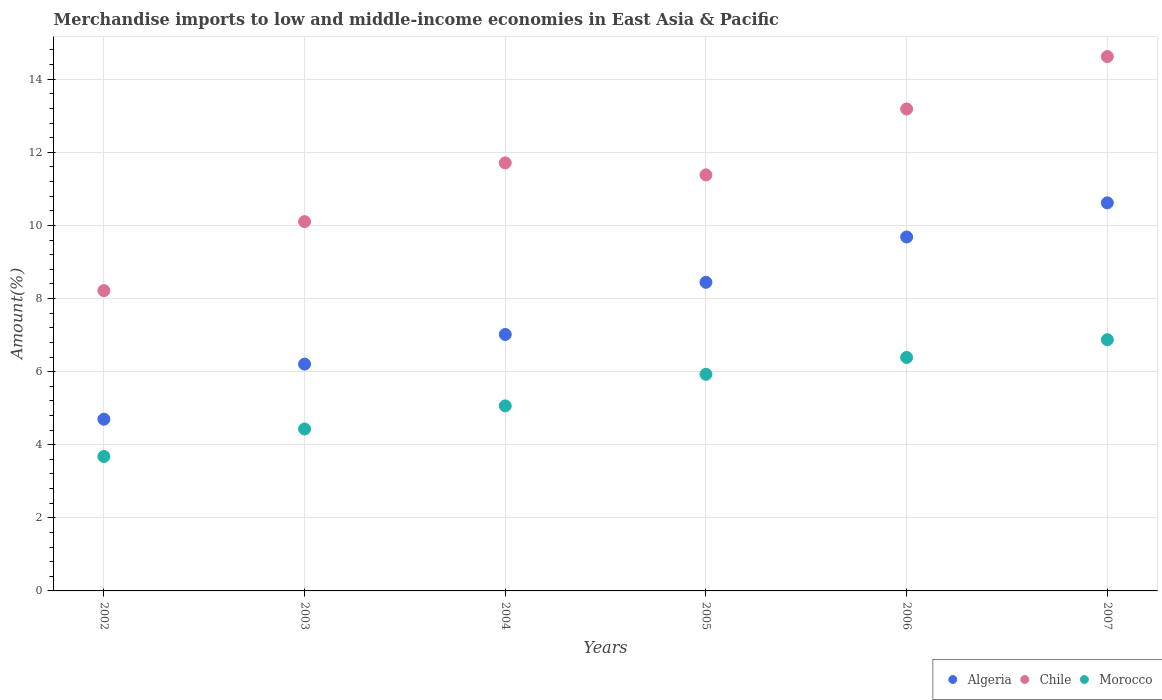How many different coloured dotlines are there?
Give a very brief answer. 3. Is the number of dotlines equal to the number of legend labels?
Offer a terse response. Yes. What is the percentage of amount earned from merchandise imports in Morocco in 2003?
Ensure brevity in your answer.  4.43. Across all years, what is the maximum percentage of amount earned from merchandise imports in Morocco?
Ensure brevity in your answer.  6.87. Across all years, what is the minimum percentage of amount earned from merchandise imports in Morocco?
Provide a succinct answer. 3.68. In which year was the percentage of amount earned from merchandise imports in Chile maximum?
Keep it short and to the point. 2007. What is the total percentage of amount earned from merchandise imports in Algeria in the graph?
Offer a terse response. 46.67. What is the difference between the percentage of amount earned from merchandise imports in Chile in 2003 and that in 2005?
Provide a short and direct response. -1.28. What is the difference between the percentage of amount earned from merchandise imports in Algeria in 2004 and the percentage of amount earned from merchandise imports in Morocco in 2007?
Offer a very short reply. 0.14. What is the average percentage of amount earned from merchandise imports in Chile per year?
Your answer should be compact. 11.54. In the year 2006, what is the difference between the percentage of amount earned from merchandise imports in Morocco and percentage of amount earned from merchandise imports in Algeria?
Keep it short and to the point. -3.3. In how many years, is the percentage of amount earned from merchandise imports in Morocco greater than 4.8 %?
Ensure brevity in your answer.  4. What is the ratio of the percentage of amount earned from merchandise imports in Morocco in 2004 to that in 2005?
Your answer should be compact. 0.85. Is the percentage of amount earned from merchandise imports in Morocco in 2002 less than that in 2004?
Keep it short and to the point. Yes. Is the difference between the percentage of amount earned from merchandise imports in Morocco in 2005 and 2007 greater than the difference between the percentage of amount earned from merchandise imports in Algeria in 2005 and 2007?
Give a very brief answer. Yes. What is the difference between the highest and the second highest percentage of amount earned from merchandise imports in Morocco?
Ensure brevity in your answer.  0.49. What is the difference between the highest and the lowest percentage of amount earned from merchandise imports in Chile?
Your answer should be compact. 6.4. Is the percentage of amount earned from merchandise imports in Morocco strictly greater than the percentage of amount earned from merchandise imports in Chile over the years?
Provide a succinct answer. No. How many dotlines are there?
Ensure brevity in your answer.  3. What is the difference between two consecutive major ticks on the Y-axis?
Provide a succinct answer. 2. Are the values on the major ticks of Y-axis written in scientific E-notation?
Keep it short and to the point. No. Does the graph contain any zero values?
Ensure brevity in your answer.  No. Does the graph contain grids?
Provide a short and direct response. Yes. How many legend labels are there?
Keep it short and to the point. 3. How are the legend labels stacked?
Offer a terse response. Horizontal. What is the title of the graph?
Offer a very short reply. Merchandise imports to low and middle-income economies in East Asia & Pacific. What is the label or title of the Y-axis?
Make the answer very short. Amount(%). What is the Amount(%) in Algeria in 2002?
Your response must be concise. 4.7. What is the Amount(%) of Chile in 2002?
Provide a succinct answer. 8.22. What is the Amount(%) in Morocco in 2002?
Your response must be concise. 3.68. What is the Amount(%) of Algeria in 2003?
Ensure brevity in your answer.  6.21. What is the Amount(%) in Chile in 2003?
Provide a short and direct response. 10.1. What is the Amount(%) in Morocco in 2003?
Your answer should be compact. 4.43. What is the Amount(%) of Algeria in 2004?
Offer a very short reply. 7.02. What is the Amount(%) of Chile in 2004?
Give a very brief answer. 11.71. What is the Amount(%) of Morocco in 2004?
Your response must be concise. 5.06. What is the Amount(%) in Algeria in 2005?
Give a very brief answer. 8.44. What is the Amount(%) in Chile in 2005?
Keep it short and to the point. 11.38. What is the Amount(%) of Morocco in 2005?
Offer a very short reply. 5.93. What is the Amount(%) in Algeria in 2006?
Offer a very short reply. 9.68. What is the Amount(%) in Chile in 2006?
Your response must be concise. 13.19. What is the Amount(%) of Morocco in 2006?
Offer a very short reply. 6.39. What is the Amount(%) in Algeria in 2007?
Keep it short and to the point. 10.62. What is the Amount(%) in Chile in 2007?
Ensure brevity in your answer.  14.62. What is the Amount(%) of Morocco in 2007?
Keep it short and to the point. 6.87. Across all years, what is the maximum Amount(%) of Algeria?
Offer a very short reply. 10.62. Across all years, what is the maximum Amount(%) of Chile?
Your answer should be very brief. 14.62. Across all years, what is the maximum Amount(%) of Morocco?
Make the answer very short. 6.87. Across all years, what is the minimum Amount(%) of Algeria?
Your response must be concise. 4.7. Across all years, what is the minimum Amount(%) of Chile?
Your response must be concise. 8.22. Across all years, what is the minimum Amount(%) of Morocco?
Your answer should be compact. 3.68. What is the total Amount(%) in Algeria in the graph?
Give a very brief answer. 46.67. What is the total Amount(%) of Chile in the graph?
Your answer should be compact. 69.22. What is the total Amount(%) of Morocco in the graph?
Ensure brevity in your answer.  32.36. What is the difference between the Amount(%) of Algeria in 2002 and that in 2003?
Your answer should be compact. -1.51. What is the difference between the Amount(%) of Chile in 2002 and that in 2003?
Your answer should be very brief. -1.89. What is the difference between the Amount(%) in Morocco in 2002 and that in 2003?
Offer a very short reply. -0.75. What is the difference between the Amount(%) of Algeria in 2002 and that in 2004?
Keep it short and to the point. -2.32. What is the difference between the Amount(%) in Chile in 2002 and that in 2004?
Your answer should be very brief. -3.49. What is the difference between the Amount(%) in Morocco in 2002 and that in 2004?
Provide a succinct answer. -1.38. What is the difference between the Amount(%) of Algeria in 2002 and that in 2005?
Your answer should be very brief. -3.75. What is the difference between the Amount(%) of Chile in 2002 and that in 2005?
Your answer should be compact. -3.17. What is the difference between the Amount(%) of Morocco in 2002 and that in 2005?
Offer a terse response. -2.25. What is the difference between the Amount(%) in Algeria in 2002 and that in 2006?
Provide a short and direct response. -4.99. What is the difference between the Amount(%) in Chile in 2002 and that in 2006?
Ensure brevity in your answer.  -4.97. What is the difference between the Amount(%) in Morocco in 2002 and that in 2006?
Make the answer very short. -2.71. What is the difference between the Amount(%) in Algeria in 2002 and that in 2007?
Provide a succinct answer. -5.92. What is the difference between the Amount(%) of Chile in 2002 and that in 2007?
Your response must be concise. -6.4. What is the difference between the Amount(%) of Morocco in 2002 and that in 2007?
Your answer should be compact. -3.19. What is the difference between the Amount(%) in Algeria in 2003 and that in 2004?
Give a very brief answer. -0.81. What is the difference between the Amount(%) in Chile in 2003 and that in 2004?
Offer a very short reply. -1.61. What is the difference between the Amount(%) of Morocco in 2003 and that in 2004?
Your response must be concise. -0.63. What is the difference between the Amount(%) of Algeria in 2003 and that in 2005?
Offer a terse response. -2.24. What is the difference between the Amount(%) of Chile in 2003 and that in 2005?
Keep it short and to the point. -1.28. What is the difference between the Amount(%) in Morocco in 2003 and that in 2005?
Offer a terse response. -1.5. What is the difference between the Amount(%) in Algeria in 2003 and that in 2006?
Your response must be concise. -3.48. What is the difference between the Amount(%) in Chile in 2003 and that in 2006?
Provide a succinct answer. -3.08. What is the difference between the Amount(%) of Morocco in 2003 and that in 2006?
Offer a terse response. -1.96. What is the difference between the Amount(%) of Algeria in 2003 and that in 2007?
Ensure brevity in your answer.  -4.41. What is the difference between the Amount(%) of Chile in 2003 and that in 2007?
Offer a terse response. -4.52. What is the difference between the Amount(%) in Morocco in 2003 and that in 2007?
Give a very brief answer. -2.44. What is the difference between the Amount(%) in Algeria in 2004 and that in 2005?
Make the answer very short. -1.43. What is the difference between the Amount(%) of Chile in 2004 and that in 2005?
Your answer should be compact. 0.33. What is the difference between the Amount(%) of Morocco in 2004 and that in 2005?
Keep it short and to the point. -0.86. What is the difference between the Amount(%) of Algeria in 2004 and that in 2006?
Your response must be concise. -2.67. What is the difference between the Amount(%) of Chile in 2004 and that in 2006?
Give a very brief answer. -1.47. What is the difference between the Amount(%) of Morocco in 2004 and that in 2006?
Ensure brevity in your answer.  -1.32. What is the difference between the Amount(%) in Algeria in 2004 and that in 2007?
Your response must be concise. -3.6. What is the difference between the Amount(%) of Chile in 2004 and that in 2007?
Give a very brief answer. -2.91. What is the difference between the Amount(%) of Morocco in 2004 and that in 2007?
Your answer should be very brief. -1.81. What is the difference between the Amount(%) of Algeria in 2005 and that in 2006?
Ensure brevity in your answer.  -1.24. What is the difference between the Amount(%) of Chile in 2005 and that in 2006?
Give a very brief answer. -1.8. What is the difference between the Amount(%) of Morocco in 2005 and that in 2006?
Your answer should be compact. -0.46. What is the difference between the Amount(%) of Algeria in 2005 and that in 2007?
Ensure brevity in your answer.  -2.17. What is the difference between the Amount(%) of Chile in 2005 and that in 2007?
Your response must be concise. -3.24. What is the difference between the Amount(%) in Morocco in 2005 and that in 2007?
Your answer should be compact. -0.95. What is the difference between the Amount(%) in Algeria in 2006 and that in 2007?
Your answer should be compact. -0.93. What is the difference between the Amount(%) in Chile in 2006 and that in 2007?
Your answer should be very brief. -1.43. What is the difference between the Amount(%) in Morocco in 2006 and that in 2007?
Give a very brief answer. -0.49. What is the difference between the Amount(%) of Algeria in 2002 and the Amount(%) of Chile in 2003?
Give a very brief answer. -5.41. What is the difference between the Amount(%) of Algeria in 2002 and the Amount(%) of Morocco in 2003?
Provide a succinct answer. 0.27. What is the difference between the Amount(%) in Chile in 2002 and the Amount(%) in Morocco in 2003?
Your response must be concise. 3.79. What is the difference between the Amount(%) of Algeria in 2002 and the Amount(%) of Chile in 2004?
Your answer should be compact. -7.01. What is the difference between the Amount(%) in Algeria in 2002 and the Amount(%) in Morocco in 2004?
Offer a terse response. -0.36. What is the difference between the Amount(%) in Chile in 2002 and the Amount(%) in Morocco in 2004?
Your answer should be compact. 3.15. What is the difference between the Amount(%) of Algeria in 2002 and the Amount(%) of Chile in 2005?
Your response must be concise. -6.68. What is the difference between the Amount(%) of Algeria in 2002 and the Amount(%) of Morocco in 2005?
Offer a terse response. -1.23. What is the difference between the Amount(%) in Chile in 2002 and the Amount(%) in Morocco in 2005?
Offer a very short reply. 2.29. What is the difference between the Amount(%) of Algeria in 2002 and the Amount(%) of Chile in 2006?
Offer a very short reply. -8.49. What is the difference between the Amount(%) of Algeria in 2002 and the Amount(%) of Morocco in 2006?
Give a very brief answer. -1.69. What is the difference between the Amount(%) of Chile in 2002 and the Amount(%) of Morocco in 2006?
Make the answer very short. 1.83. What is the difference between the Amount(%) of Algeria in 2002 and the Amount(%) of Chile in 2007?
Ensure brevity in your answer.  -9.92. What is the difference between the Amount(%) in Algeria in 2002 and the Amount(%) in Morocco in 2007?
Offer a very short reply. -2.18. What is the difference between the Amount(%) of Chile in 2002 and the Amount(%) of Morocco in 2007?
Ensure brevity in your answer.  1.34. What is the difference between the Amount(%) of Algeria in 2003 and the Amount(%) of Chile in 2004?
Offer a terse response. -5.5. What is the difference between the Amount(%) in Algeria in 2003 and the Amount(%) in Morocco in 2004?
Your answer should be very brief. 1.14. What is the difference between the Amount(%) in Chile in 2003 and the Amount(%) in Morocco in 2004?
Your answer should be compact. 5.04. What is the difference between the Amount(%) in Algeria in 2003 and the Amount(%) in Chile in 2005?
Ensure brevity in your answer.  -5.18. What is the difference between the Amount(%) of Algeria in 2003 and the Amount(%) of Morocco in 2005?
Provide a succinct answer. 0.28. What is the difference between the Amount(%) in Chile in 2003 and the Amount(%) in Morocco in 2005?
Keep it short and to the point. 4.18. What is the difference between the Amount(%) of Algeria in 2003 and the Amount(%) of Chile in 2006?
Your response must be concise. -6.98. What is the difference between the Amount(%) of Algeria in 2003 and the Amount(%) of Morocco in 2006?
Ensure brevity in your answer.  -0.18. What is the difference between the Amount(%) in Chile in 2003 and the Amount(%) in Morocco in 2006?
Give a very brief answer. 3.72. What is the difference between the Amount(%) in Algeria in 2003 and the Amount(%) in Chile in 2007?
Your answer should be compact. -8.41. What is the difference between the Amount(%) in Algeria in 2003 and the Amount(%) in Morocco in 2007?
Your response must be concise. -0.67. What is the difference between the Amount(%) in Chile in 2003 and the Amount(%) in Morocco in 2007?
Provide a short and direct response. 3.23. What is the difference between the Amount(%) in Algeria in 2004 and the Amount(%) in Chile in 2005?
Ensure brevity in your answer.  -4.37. What is the difference between the Amount(%) in Algeria in 2004 and the Amount(%) in Morocco in 2005?
Your answer should be compact. 1.09. What is the difference between the Amount(%) of Chile in 2004 and the Amount(%) of Morocco in 2005?
Make the answer very short. 5.78. What is the difference between the Amount(%) in Algeria in 2004 and the Amount(%) in Chile in 2006?
Your answer should be very brief. -6.17. What is the difference between the Amount(%) of Algeria in 2004 and the Amount(%) of Morocco in 2006?
Provide a short and direct response. 0.63. What is the difference between the Amount(%) in Chile in 2004 and the Amount(%) in Morocco in 2006?
Offer a terse response. 5.32. What is the difference between the Amount(%) in Algeria in 2004 and the Amount(%) in Chile in 2007?
Keep it short and to the point. -7.6. What is the difference between the Amount(%) of Algeria in 2004 and the Amount(%) of Morocco in 2007?
Provide a succinct answer. 0.14. What is the difference between the Amount(%) of Chile in 2004 and the Amount(%) of Morocco in 2007?
Offer a terse response. 4.84. What is the difference between the Amount(%) in Algeria in 2005 and the Amount(%) in Chile in 2006?
Keep it short and to the point. -4.74. What is the difference between the Amount(%) in Algeria in 2005 and the Amount(%) in Morocco in 2006?
Keep it short and to the point. 2.06. What is the difference between the Amount(%) in Chile in 2005 and the Amount(%) in Morocco in 2006?
Your answer should be compact. 5. What is the difference between the Amount(%) of Algeria in 2005 and the Amount(%) of Chile in 2007?
Your answer should be compact. -6.18. What is the difference between the Amount(%) of Algeria in 2005 and the Amount(%) of Morocco in 2007?
Your answer should be very brief. 1.57. What is the difference between the Amount(%) of Chile in 2005 and the Amount(%) of Morocco in 2007?
Your answer should be compact. 4.51. What is the difference between the Amount(%) in Algeria in 2006 and the Amount(%) in Chile in 2007?
Keep it short and to the point. -4.94. What is the difference between the Amount(%) in Algeria in 2006 and the Amount(%) in Morocco in 2007?
Offer a very short reply. 2.81. What is the difference between the Amount(%) in Chile in 2006 and the Amount(%) in Morocco in 2007?
Give a very brief answer. 6.31. What is the average Amount(%) in Algeria per year?
Offer a very short reply. 7.78. What is the average Amount(%) in Chile per year?
Offer a very short reply. 11.54. What is the average Amount(%) of Morocco per year?
Provide a short and direct response. 5.39. In the year 2002, what is the difference between the Amount(%) of Algeria and Amount(%) of Chile?
Your answer should be compact. -3.52. In the year 2002, what is the difference between the Amount(%) of Algeria and Amount(%) of Morocco?
Your answer should be compact. 1.02. In the year 2002, what is the difference between the Amount(%) of Chile and Amount(%) of Morocco?
Provide a succinct answer. 4.54. In the year 2003, what is the difference between the Amount(%) in Algeria and Amount(%) in Chile?
Your answer should be compact. -3.9. In the year 2003, what is the difference between the Amount(%) in Algeria and Amount(%) in Morocco?
Your answer should be compact. 1.78. In the year 2003, what is the difference between the Amount(%) of Chile and Amount(%) of Morocco?
Your answer should be compact. 5.67. In the year 2004, what is the difference between the Amount(%) of Algeria and Amount(%) of Chile?
Your answer should be very brief. -4.69. In the year 2004, what is the difference between the Amount(%) of Algeria and Amount(%) of Morocco?
Keep it short and to the point. 1.95. In the year 2004, what is the difference between the Amount(%) of Chile and Amount(%) of Morocco?
Keep it short and to the point. 6.65. In the year 2005, what is the difference between the Amount(%) of Algeria and Amount(%) of Chile?
Make the answer very short. -2.94. In the year 2005, what is the difference between the Amount(%) of Algeria and Amount(%) of Morocco?
Ensure brevity in your answer.  2.52. In the year 2005, what is the difference between the Amount(%) in Chile and Amount(%) in Morocco?
Offer a very short reply. 5.46. In the year 2006, what is the difference between the Amount(%) of Algeria and Amount(%) of Chile?
Your answer should be very brief. -3.5. In the year 2006, what is the difference between the Amount(%) of Algeria and Amount(%) of Morocco?
Provide a succinct answer. 3.3. In the year 2006, what is the difference between the Amount(%) in Chile and Amount(%) in Morocco?
Ensure brevity in your answer.  6.8. In the year 2007, what is the difference between the Amount(%) in Algeria and Amount(%) in Chile?
Ensure brevity in your answer.  -4. In the year 2007, what is the difference between the Amount(%) of Algeria and Amount(%) of Morocco?
Provide a succinct answer. 3.74. In the year 2007, what is the difference between the Amount(%) of Chile and Amount(%) of Morocco?
Offer a very short reply. 7.75. What is the ratio of the Amount(%) in Algeria in 2002 to that in 2003?
Ensure brevity in your answer.  0.76. What is the ratio of the Amount(%) of Chile in 2002 to that in 2003?
Your answer should be compact. 0.81. What is the ratio of the Amount(%) in Morocco in 2002 to that in 2003?
Offer a terse response. 0.83. What is the ratio of the Amount(%) in Algeria in 2002 to that in 2004?
Give a very brief answer. 0.67. What is the ratio of the Amount(%) of Chile in 2002 to that in 2004?
Provide a short and direct response. 0.7. What is the ratio of the Amount(%) of Morocco in 2002 to that in 2004?
Your answer should be very brief. 0.73. What is the ratio of the Amount(%) in Algeria in 2002 to that in 2005?
Make the answer very short. 0.56. What is the ratio of the Amount(%) of Chile in 2002 to that in 2005?
Ensure brevity in your answer.  0.72. What is the ratio of the Amount(%) of Morocco in 2002 to that in 2005?
Offer a very short reply. 0.62. What is the ratio of the Amount(%) of Algeria in 2002 to that in 2006?
Offer a terse response. 0.49. What is the ratio of the Amount(%) in Chile in 2002 to that in 2006?
Give a very brief answer. 0.62. What is the ratio of the Amount(%) in Morocco in 2002 to that in 2006?
Ensure brevity in your answer.  0.58. What is the ratio of the Amount(%) of Algeria in 2002 to that in 2007?
Offer a terse response. 0.44. What is the ratio of the Amount(%) of Chile in 2002 to that in 2007?
Provide a succinct answer. 0.56. What is the ratio of the Amount(%) in Morocco in 2002 to that in 2007?
Ensure brevity in your answer.  0.54. What is the ratio of the Amount(%) of Algeria in 2003 to that in 2004?
Provide a short and direct response. 0.88. What is the ratio of the Amount(%) in Chile in 2003 to that in 2004?
Ensure brevity in your answer.  0.86. What is the ratio of the Amount(%) of Morocco in 2003 to that in 2004?
Your response must be concise. 0.88. What is the ratio of the Amount(%) in Algeria in 2003 to that in 2005?
Your answer should be compact. 0.73. What is the ratio of the Amount(%) of Chile in 2003 to that in 2005?
Keep it short and to the point. 0.89. What is the ratio of the Amount(%) of Morocco in 2003 to that in 2005?
Provide a succinct answer. 0.75. What is the ratio of the Amount(%) in Algeria in 2003 to that in 2006?
Give a very brief answer. 0.64. What is the ratio of the Amount(%) of Chile in 2003 to that in 2006?
Offer a very short reply. 0.77. What is the ratio of the Amount(%) of Morocco in 2003 to that in 2006?
Ensure brevity in your answer.  0.69. What is the ratio of the Amount(%) of Algeria in 2003 to that in 2007?
Provide a short and direct response. 0.58. What is the ratio of the Amount(%) in Chile in 2003 to that in 2007?
Your response must be concise. 0.69. What is the ratio of the Amount(%) in Morocco in 2003 to that in 2007?
Your answer should be compact. 0.64. What is the ratio of the Amount(%) in Algeria in 2004 to that in 2005?
Provide a succinct answer. 0.83. What is the ratio of the Amount(%) in Chile in 2004 to that in 2005?
Ensure brevity in your answer.  1.03. What is the ratio of the Amount(%) of Morocco in 2004 to that in 2005?
Ensure brevity in your answer.  0.85. What is the ratio of the Amount(%) in Algeria in 2004 to that in 2006?
Keep it short and to the point. 0.72. What is the ratio of the Amount(%) of Chile in 2004 to that in 2006?
Your answer should be very brief. 0.89. What is the ratio of the Amount(%) in Morocco in 2004 to that in 2006?
Offer a very short reply. 0.79. What is the ratio of the Amount(%) in Algeria in 2004 to that in 2007?
Provide a succinct answer. 0.66. What is the ratio of the Amount(%) of Chile in 2004 to that in 2007?
Your answer should be very brief. 0.8. What is the ratio of the Amount(%) of Morocco in 2004 to that in 2007?
Ensure brevity in your answer.  0.74. What is the ratio of the Amount(%) in Algeria in 2005 to that in 2006?
Provide a succinct answer. 0.87. What is the ratio of the Amount(%) in Chile in 2005 to that in 2006?
Offer a very short reply. 0.86. What is the ratio of the Amount(%) of Morocco in 2005 to that in 2006?
Your response must be concise. 0.93. What is the ratio of the Amount(%) of Algeria in 2005 to that in 2007?
Make the answer very short. 0.8. What is the ratio of the Amount(%) of Chile in 2005 to that in 2007?
Offer a very short reply. 0.78. What is the ratio of the Amount(%) of Morocco in 2005 to that in 2007?
Provide a short and direct response. 0.86. What is the ratio of the Amount(%) of Algeria in 2006 to that in 2007?
Make the answer very short. 0.91. What is the ratio of the Amount(%) of Chile in 2006 to that in 2007?
Your answer should be very brief. 0.9. What is the ratio of the Amount(%) in Morocco in 2006 to that in 2007?
Your response must be concise. 0.93. What is the difference between the highest and the second highest Amount(%) in Algeria?
Provide a short and direct response. 0.93. What is the difference between the highest and the second highest Amount(%) of Chile?
Offer a terse response. 1.43. What is the difference between the highest and the second highest Amount(%) in Morocco?
Your response must be concise. 0.49. What is the difference between the highest and the lowest Amount(%) of Algeria?
Your answer should be very brief. 5.92. What is the difference between the highest and the lowest Amount(%) of Chile?
Your response must be concise. 6.4. What is the difference between the highest and the lowest Amount(%) in Morocco?
Give a very brief answer. 3.19. 